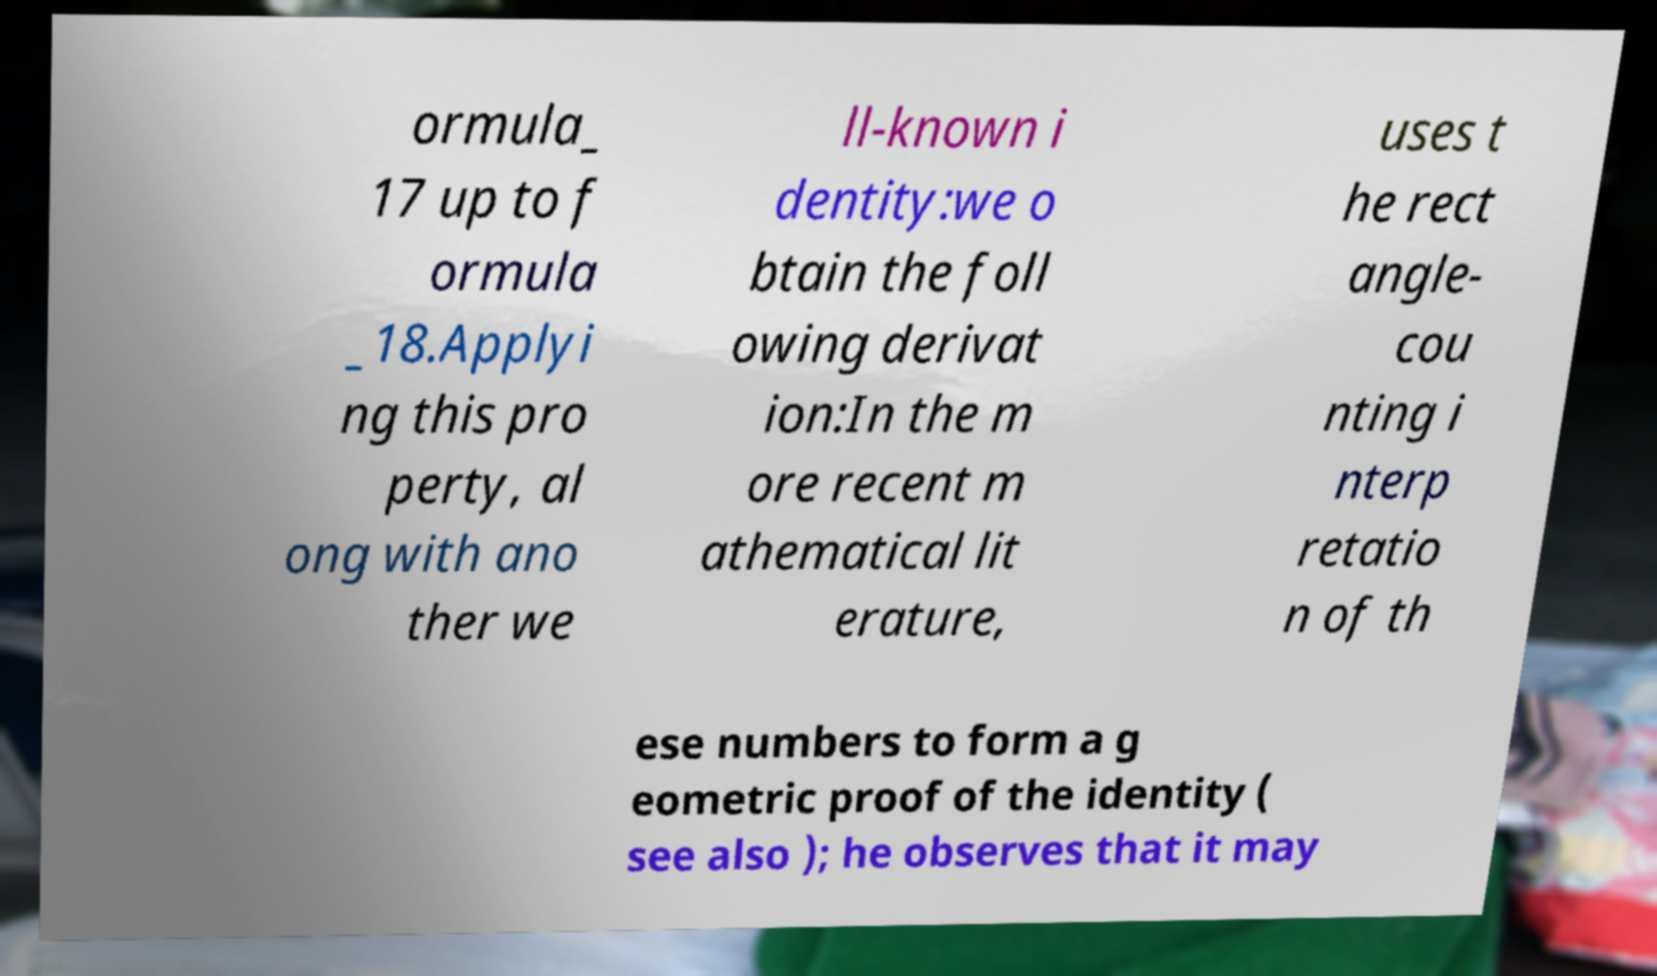Could you extract and type out the text from this image? ormula_ 17 up to f ormula _18.Applyi ng this pro perty, al ong with ano ther we ll-known i dentity:we o btain the foll owing derivat ion:In the m ore recent m athematical lit erature, uses t he rect angle- cou nting i nterp retatio n of th ese numbers to form a g eometric proof of the identity ( see also ); he observes that it may 